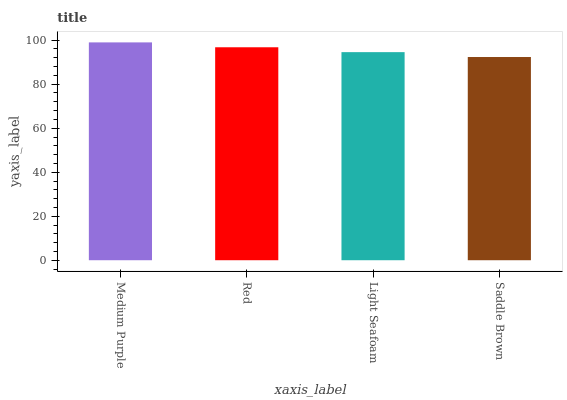Is Saddle Brown the minimum?
Answer yes or no. Yes. Is Medium Purple the maximum?
Answer yes or no. Yes. Is Red the minimum?
Answer yes or no. No. Is Red the maximum?
Answer yes or no. No. Is Medium Purple greater than Red?
Answer yes or no. Yes. Is Red less than Medium Purple?
Answer yes or no. Yes. Is Red greater than Medium Purple?
Answer yes or no. No. Is Medium Purple less than Red?
Answer yes or no. No. Is Red the high median?
Answer yes or no. Yes. Is Light Seafoam the low median?
Answer yes or no. Yes. Is Saddle Brown the high median?
Answer yes or no. No. Is Medium Purple the low median?
Answer yes or no. No. 